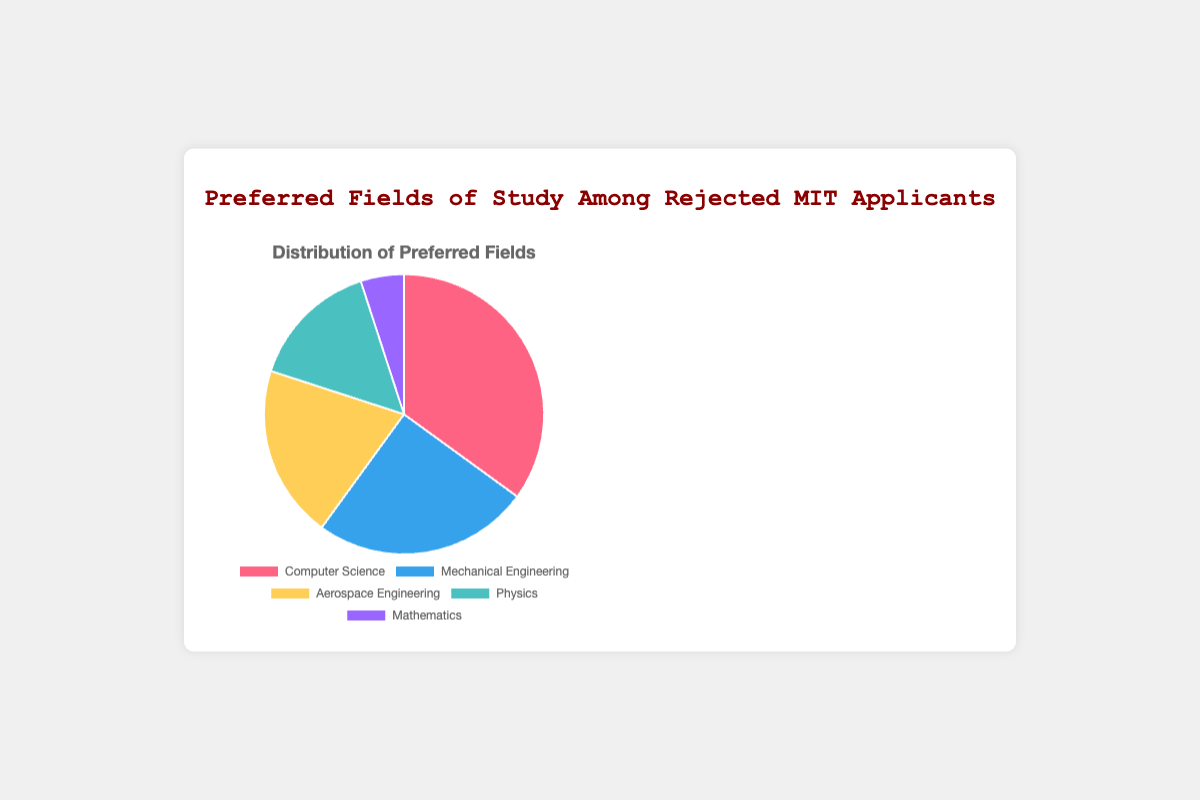What is the majority field of study among rejected applicants? The largest portion of the pie chart is related to Computer Science, at 35%. This slice is visibly the largest compared to others, indicating it is the majority.
Answer: Computer Science How much larger is the Computer Science slice compared to the Mathematics slice? Computer Science has 35% while Mathematics has 5%. The difference is 35% - 5%.
Answer: 30% What is the combined percentage of Aerospace Engineering and Mechanical Engineering? Aerospace Engineering represents 20% and Mechanical Engineering represents 25%. Their combined percentage is 20% + 25%.
Answer: 45% Which slice is smaller, Physics or Mathematics? Physics is represented as 15% and Mathematics is represented as 5%. Comparing these two values, Mathematics is smaller.
Answer: Mathematics What two fields together make up half of the pie chart? Mechanically summing the percentages, the two fields whose combined total is close to 50% are Computer Science (35%) and Aerospace Engineering (20%). Together, they make up more than half (35% + 20% = 55%). However, the closest to exactly half is Mechanical Engineering (25%) + Computer Science (35%) = 60%.
Answer: None (closest is Mechanical Engineering and Computer Science) By how many percentage points does Mechanical Engineering exceed Physics? Mechanical Engineering is at 25% and Physics is at 15%, so the difference is 25% - 15%.
Answer: 10% What is the least preferred field of study among rejected applicants? The smallest section of the pie chart corresponds to Mathematics, at 5%.
Answer: Mathematics Out of the fields of Mechanical Engineering and Aerospace Engineering, which one has a higher representation and by how much? Mechanical Engineering is at 25%, Aerospace Engineering is at 20%. The difference is 25% - 20%.
Answer: Mechanical Engineering by 5% What percent of the rejected applicants chose fields other than Computer Science? Subtract the percentage of applicants who preferred Computer Science (35%) from 100%. So, 100% - 35%.
Answer: 65% 